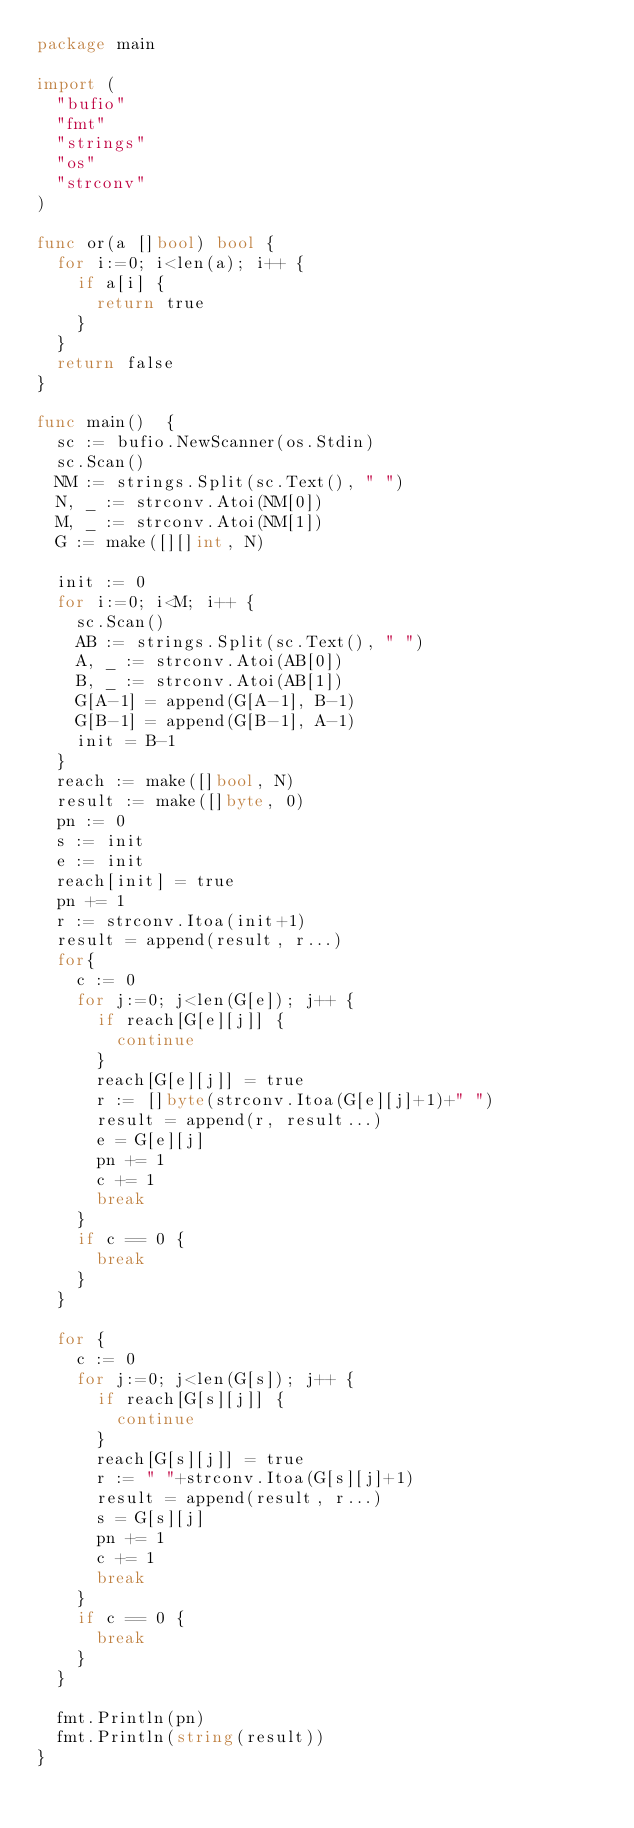<code> <loc_0><loc_0><loc_500><loc_500><_Go_>package main

import (
  "bufio"
  "fmt"
  "strings"
  "os"
  "strconv"
)

func or(a []bool) bool {
  for i:=0; i<len(a); i++ {
    if a[i] {
      return true
    }
  }
  return false
}

func main()  {
  sc := bufio.NewScanner(os.Stdin)
  sc.Scan()
  NM := strings.Split(sc.Text(), " ")
  N, _ := strconv.Atoi(NM[0])
  M, _ := strconv.Atoi(NM[1])
  G := make([][]int, N)

  init := 0
  for i:=0; i<M; i++ {
    sc.Scan()
    AB := strings.Split(sc.Text(), " ")
    A, _ := strconv.Atoi(AB[0])
    B, _ := strconv.Atoi(AB[1])
    G[A-1] = append(G[A-1], B-1)
    G[B-1] = append(G[B-1], A-1)
    init = B-1
  }
  reach := make([]bool, N)
  result := make([]byte, 0)
  pn := 0
  s := init
  e := init
  reach[init] = true
  pn += 1
  r := strconv.Itoa(init+1)
  result = append(result, r...)
  for{
    c := 0
    for j:=0; j<len(G[e]); j++ {
      if reach[G[e][j]] {
        continue
      }
      reach[G[e][j]] = true
      r := []byte(strconv.Itoa(G[e][j]+1)+" ")
      result = append(r, result...)
      e = G[e][j]
      pn += 1
      c += 1
      break
    }
    if c == 0 {
      break
    }
  }

  for {
    c := 0
    for j:=0; j<len(G[s]); j++ {
      if reach[G[s][j]] {
        continue
      }
      reach[G[s][j]] = true
      r := " "+strconv.Itoa(G[s][j]+1)
      result = append(result, r...)
      s = G[s][j]
      pn += 1
      c += 1
      break
    }
    if c == 0 {
      break
    }
  }

  fmt.Println(pn)
  fmt.Println(string(result))
}
</code> 